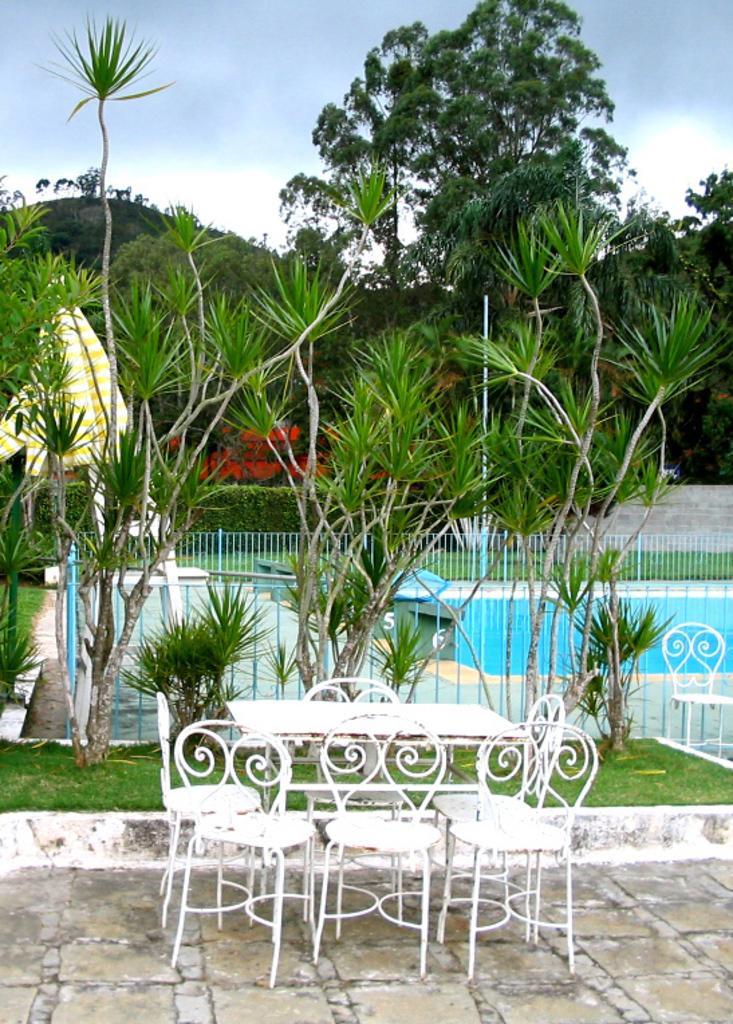In one or two sentences, can you explain what this image depicts? There is a table and chairs present at the bottom of this image. We can see trees and a fence in the middle of this image. There is a sky at the top of this image. 